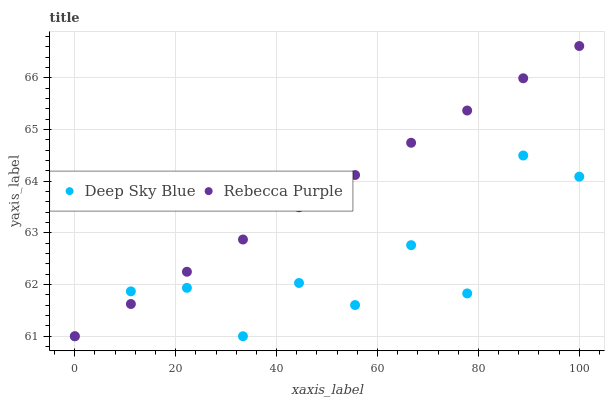Does Deep Sky Blue have the minimum area under the curve?
Answer yes or no. Yes. Does Rebecca Purple have the maximum area under the curve?
Answer yes or no. Yes. Does Deep Sky Blue have the maximum area under the curve?
Answer yes or no. No. Is Rebecca Purple the smoothest?
Answer yes or no. Yes. Is Deep Sky Blue the roughest?
Answer yes or no. Yes. Is Deep Sky Blue the smoothest?
Answer yes or no. No. Does Rebecca Purple have the lowest value?
Answer yes or no. Yes. Does Rebecca Purple have the highest value?
Answer yes or no. Yes. Does Deep Sky Blue have the highest value?
Answer yes or no. No. Does Deep Sky Blue intersect Rebecca Purple?
Answer yes or no. Yes. Is Deep Sky Blue less than Rebecca Purple?
Answer yes or no. No. Is Deep Sky Blue greater than Rebecca Purple?
Answer yes or no. No. 